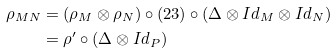<formula> <loc_0><loc_0><loc_500><loc_500>\rho _ { M N } & = ( \rho _ { M } \otimes \rho _ { N } ) \circ ( 2 3 ) \circ ( \Delta \otimes I d _ { M } \otimes I d _ { N } ) \\ & = \rho ^ { \prime } \circ ( \Delta \otimes I d _ { P } )</formula> 